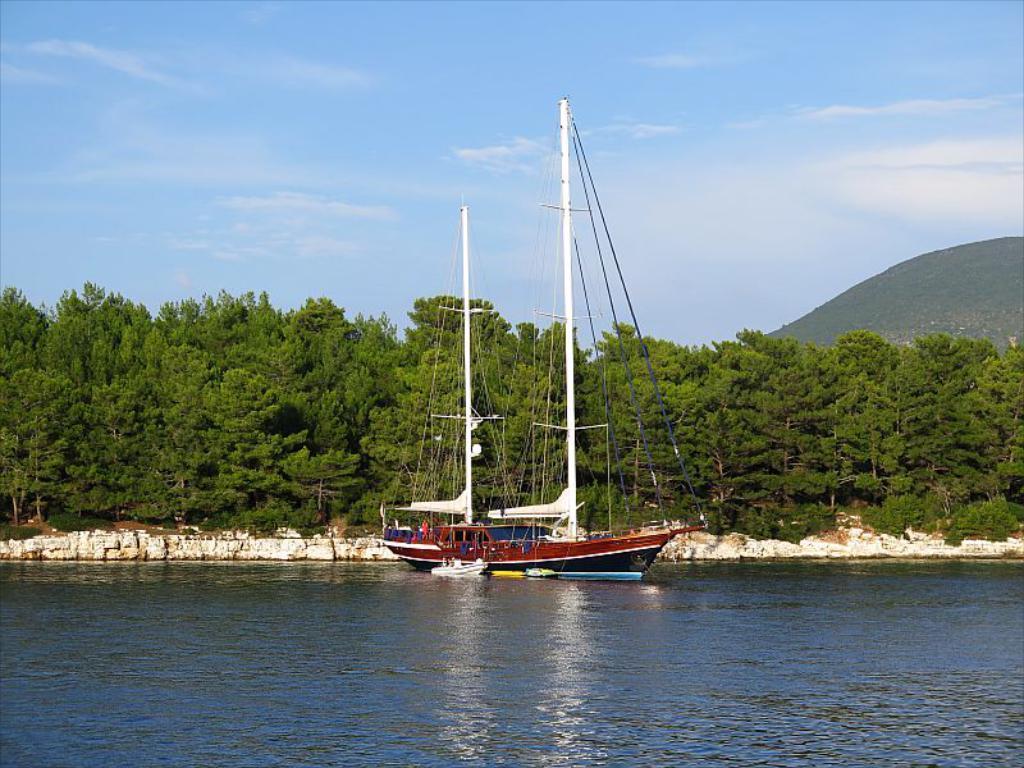Can you describe this image briefly? In this image at the bottom there is a river, and in the center there is a ship and some trees and wall and sand. And in the background there are mountains, and at the top there is sky. 